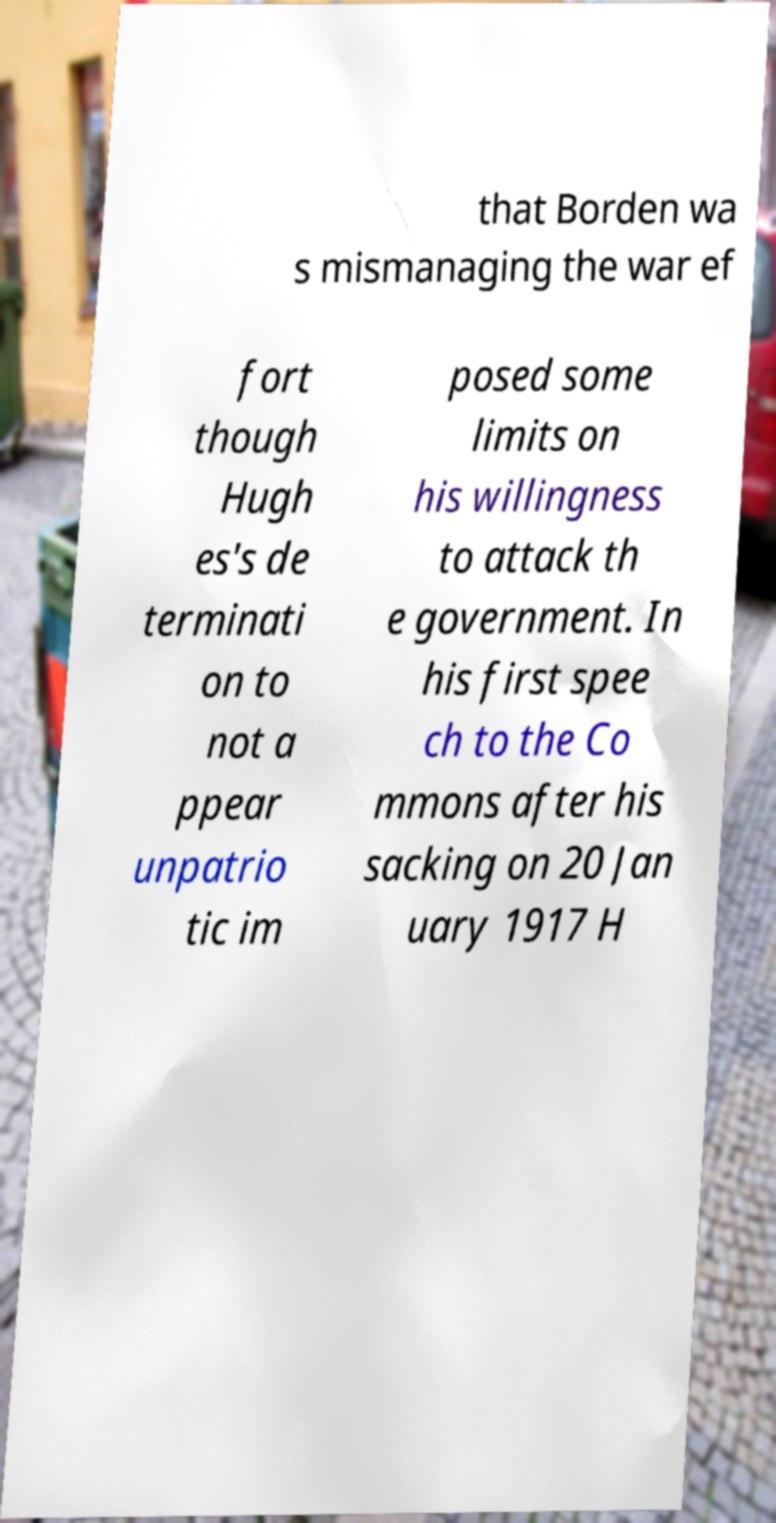What messages or text are displayed in this image? I need them in a readable, typed format. that Borden wa s mismanaging the war ef fort though Hugh es's de terminati on to not a ppear unpatrio tic im posed some limits on his willingness to attack th e government. In his first spee ch to the Co mmons after his sacking on 20 Jan uary 1917 H 